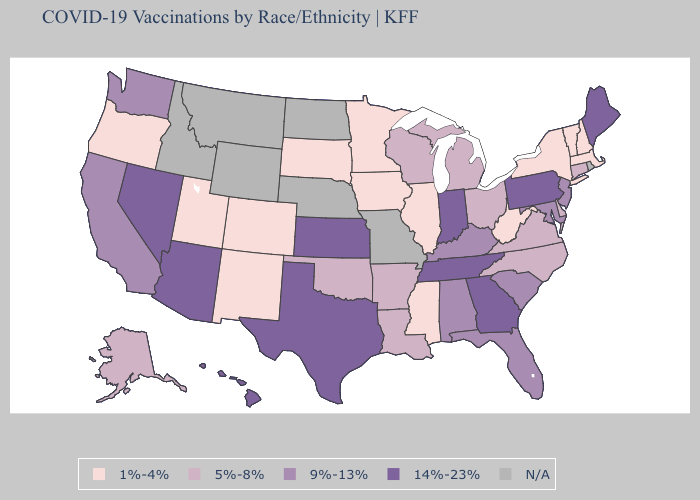Does New Jersey have the lowest value in the Northeast?
Concise answer only. No. Name the states that have a value in the range 9%-13%?
Answer briefly. Alabama, California, Florida, Kentucky, Maryland, New Jersey, South Carolina, Washington. What is the lowest value in the USA?
Answer briefly. 1%-4%. Name the states that have a value in the range 1%-4%?
Be succinct. Colorado, Illinois, Iowa, Massachusetts, Minnesota, Mississippi, New Hampshire, New Mexico, New York, Oregon, South Dakota, Utah, Vermont, West Virginia. What is the value of Nevada?
Answer briefly. 14%-23%. What is the value of Nebraska?
Concise answer only. N/A. Which states hav the highest value in the West?
Concise answer only. Arizona, Hawaii, Nevada. How many symbols are there in the legend?
Be succinct. 5. What is the lowest value in states that border Tennessee?
Keep it brief. 1%-4%. Does the first symbol in the legend represent the smallest category?
Short answer required. Yes. Name the states that have a value in the range 9%-13%?
Answer briefly. Alabama, California, Florida, Kentucky, Maryland, New Jersey, South Carolina, Washington. Does the map have missing data?
Quick response, please. Yes. 